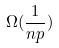Convert formula to latex. <formula><loc_0><loc_0><loc_500><loc_500>\Omega ( \frac { 1 } { n p } )</formula> 